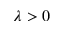Convert formula to latex. <formula><loc_0><loc_0><loc_500><loc_500>\lambda > 0</formula> 